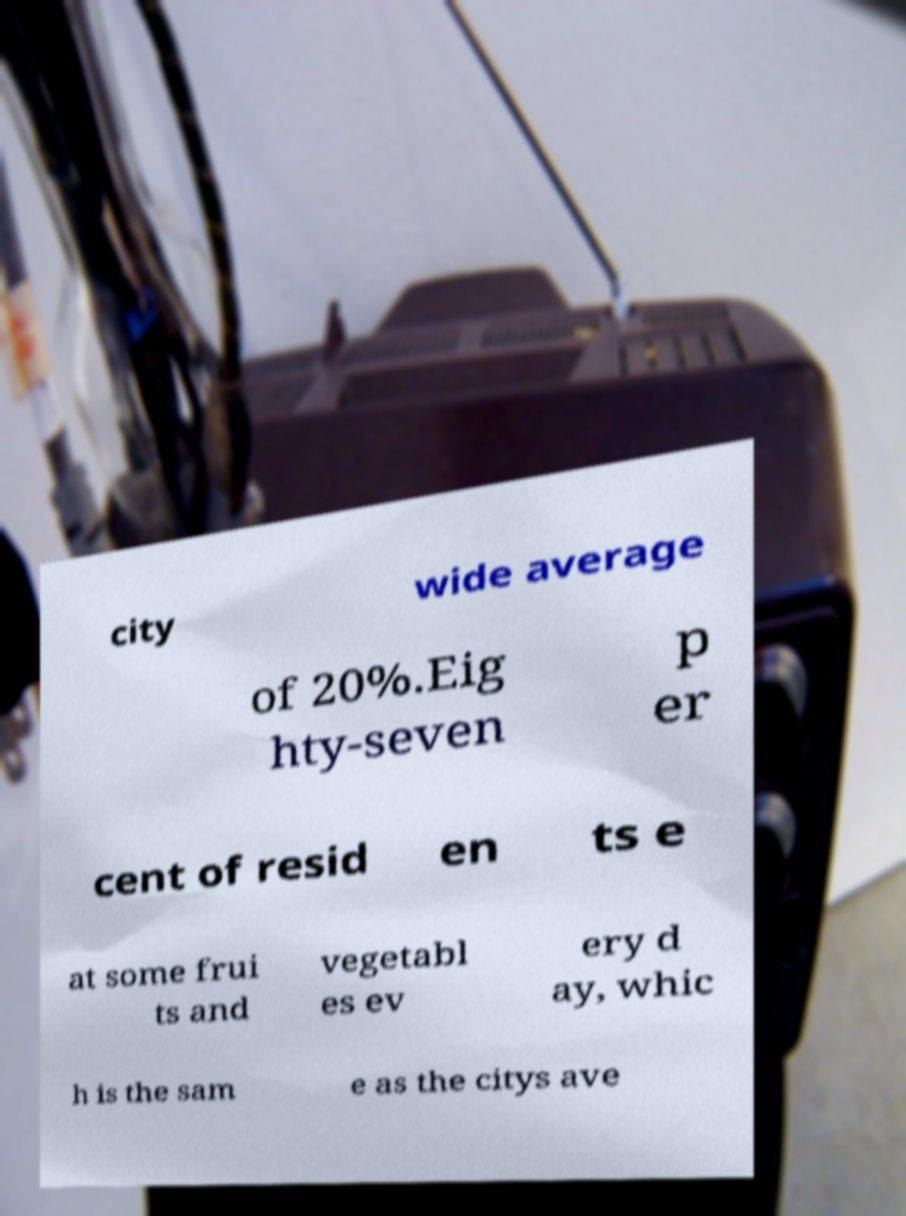There's text embedded in this image that I need extracted. Can you transcribe it verbatim? city wide average of 20%.Eig hty-seven p er cent of resid en ts e at some frui ts and vegetabl es ev ery d ay, whic h is the sam e as the citys ave 